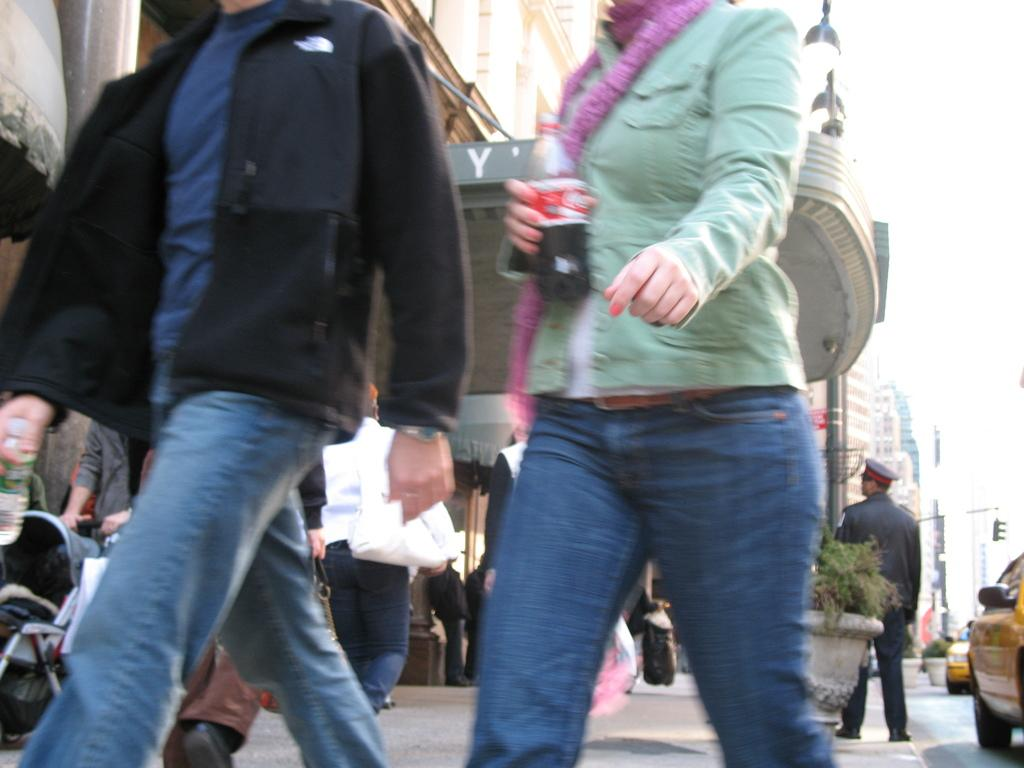Who or what can be seen in the image? There are people in the image. What else is present in the image besides people? There are cars, a pot, plants, buildings, and the sky is visible in the image. What type of space mission is being conducted in the image? There is no space mission or any reference to space in the image. 